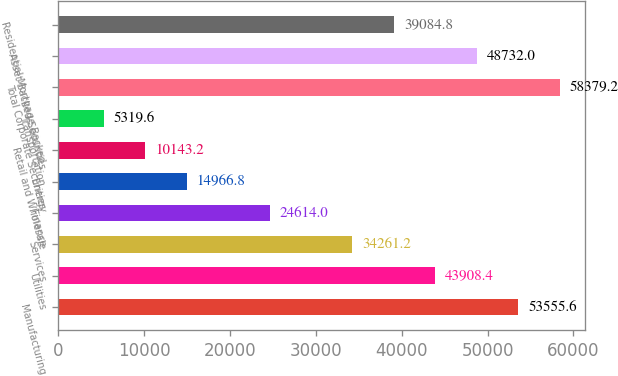Convert chart to OTSL. <chart><loc_0><loc_0><loc_500><loc_500><bar_chart><fcel>Manufacturing<fcel>Utilities<fcel>Services<fcel>Finance<fcel>Energy<fcel>Retail and Wholesale<fcel>Transportation<fcel>Total Corporate Securities<fcel>Asset-Backed Securities<fcel>Residential Mortgage Backed<nl><fcel>53555.6<fcel>43908.4<fcel>34261.2<fcel>24614<fcel>14966.8<fcel>10143.2<fcel>5319.6<fcel>58379.2<fcel>48732<fcel>39084.8<nl></chart> 